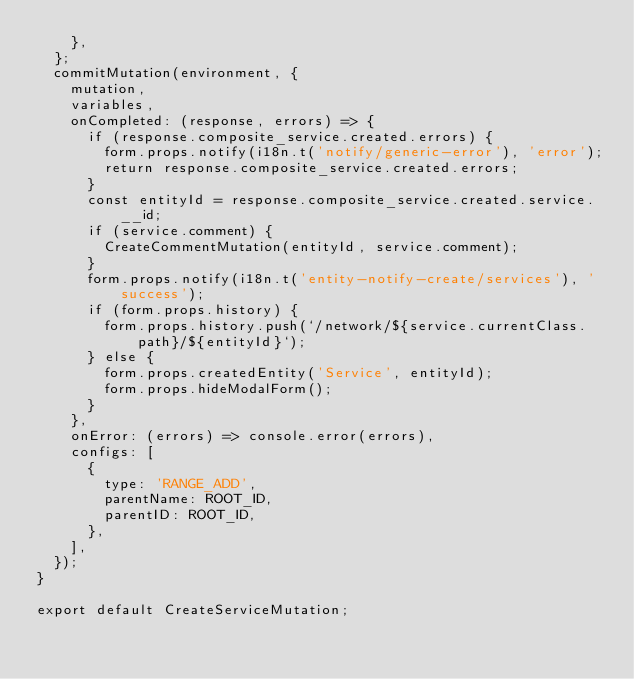Convert code to text. <code><loc_0><loc_0><loc_500><loc_500><_JavaScript_>    },
  };
  commitMutation(environment, {
    mutation,
    variables,
    onCompleted: (response, errors) => {
      if (response.composite_service.created.errors) {
        form.props.notify(i18n.t('notify/generic-error'), 'error');
        return response.composite_service.created.errors;
      }
      const entityId = response.composite_service.created.service.__id;
      if (service.comment) {
        CreateCommentMutation(entityId, service.comment);
      }
      form.props.notify(i18n.t('entity-notify-create/services'), 'success');
      if (form.props.history) {
        form.props.history.push(`/network/${service.currentClass.path}/${entityId}`);
      } else {
        form.props.createdEntity('Service', entityId);
        form.props.hideModalForm();
      }
    },
    onError: (errors) => console.error(errors),
    configs: [
      {
        type: 'RANGE_ADD',
        parentName: ROOT_ID,
        parentID: ROOT_ID,
      },
    ],
  });
}

export default CreateServiceMutation;
</code> 